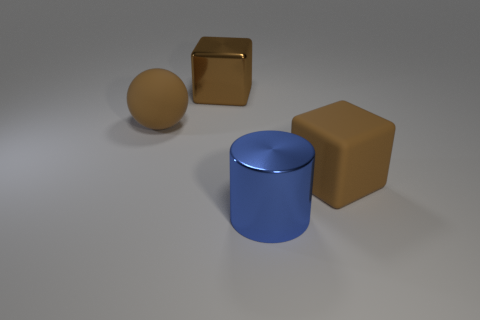Add 4 big red blocks. How many objects exist? 8 Subtract 0 cyan cylinders. How many objects are left? 4 Subtract all purple cylinders. Subtract all cyan cubes. How many cylinders are left? 1 Subtract all yellow matte cylinders. Subtract all brown rubber cubes. How many objects are left? 3 Add 3 cubes. How many cubes are left? 5 Add 4 tiny cyan shiny cylinders. How many tiny cyan shiny cylinders exist? 4 